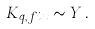<formula> <loc_0><loc_0><loc_500><loc_500>K _ { q , f i x } \sim Y \, .</formula> 